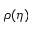<formula> <loc_0><loc_0><loc_500><loc_500>\rho ( \eta )</formula> 